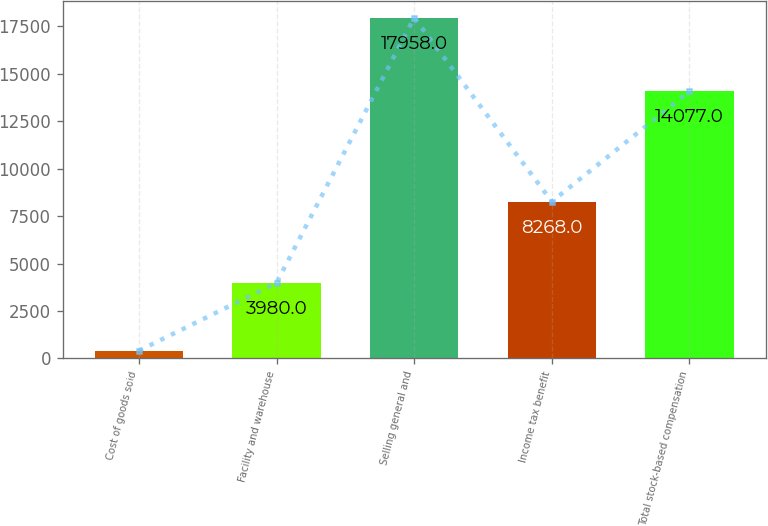Convert chart to OTSL. <chart><loc_0><loc_0><loc_500><loc_500><bar_chart><fcel>Cost of goods sold<fcel>Facility and warehouse<fcel>Selling general and<fcel>Income tax benefit<fcel>Total stock-based compensation<nl><fcel>407<fcel>3980<fcel>17958<fcel>8268<fcel>14077<nl></chart> 